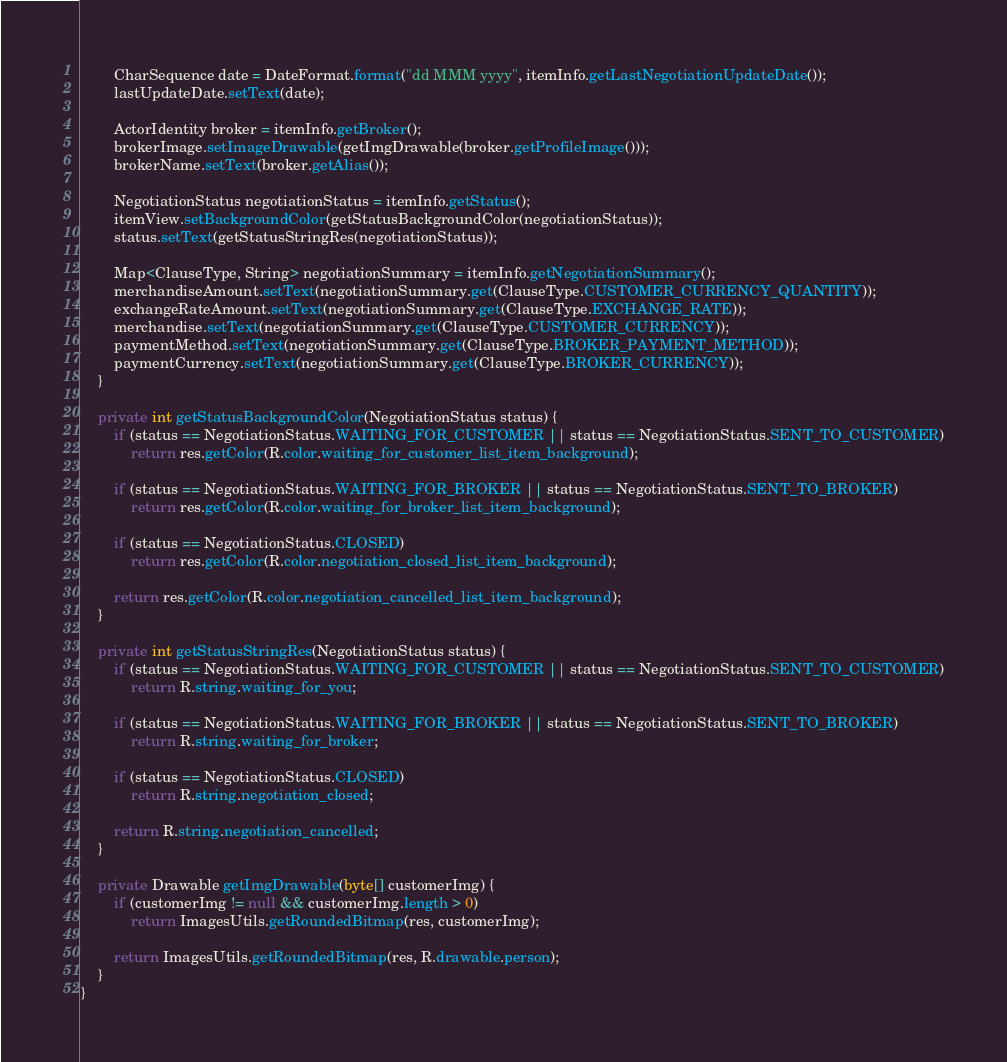Convert code to text. <code><loc_0><loc_0><loc_500><loc_500><_Java_>        CharSequence date = DateFormat.format("dd MMM yyyy", itemInfo.getLastNegotiationUpdateDate());
        lastUpdateDate.setText(date);

        ActorIdentity broker = itemInfo.getBroker();
        brokerImage.setImageDrawable(getImgDrawable(broker.getProfileImage()));
        brokerName.setText(broker.getAlias());

        NegotiationStatus negotiationStatus = itemInfo.getStatus();
        itemView.setBackgroundColor(getStatusBackgroundColor(negotiationStatus));
        status.setText(getStatusStringRes(negotiationStatus));

        Map<ClauseType, String> negotiationSummary = itemInfo.getNegotiationSummary();
        merchandiseAmount.setText(negotiationSummary.get(ClauseType.CUSTOMER_CURRENCY_QUANTITY));
        exchangeRateAmount.setText(negotiationSummary.get(ClauseType.EXCHANGE_RATE));
        merchandise.setText(negotiationSummary.get(ClauseType.CUSTOMER_CURRENCY));
        paymentMethod.setText(negotiationSummary.get(ClauseType.BROKER_PAYMENT_METHOD));
        paymentCurrency.setText(negotiationSummary.get(ClauseType.BROKER_CURRENCY));
    }

    private int getStatusBackgroundColor(NegotiationStatus status) {
        if (status == NegotiationStatus.WAITING_FOR_CUSTOMER || status == NegotiationStatus.SENT_TO_CUSTOMER)
            return res.getColor(R.color.waiting_for_customer_list_item_background);

        if (status == NegotiationStatus.WAITING_FOR_BROKER || status == NegotiationStatus.SENT_TO_BROKER)
            return res.getColor(R.color.waiting_for_broker_list_item_background);

        if (status == NegotiationStatus.CLOSED)
            return res.getColor(R.color.negotiation_closed_list_item_background);

        return res.getColor(R.color.negotiation_cancelled_list_item_background);
    }

    private int getStatusStringRes(NegotiationStatus status) {
        if (status == NegotiationStatus.WAITING_FOR_CUSTOMER || status == NegotiationStatus.SENT_TO_CUSTOMER)
            return R.string.waiting_for_you;

        if (status == NegotiationStatus.WAITING_FOR_BROKER || status == NegotiationStatus.SENT_TO_BROKER)
            return R.string.waiting_for_broker;

        if (status == NegotiationStatus.CLOSED)
            return R.string.negotiation_closed;

        return R.string.negotiation_cancelled;
    }

    private Drawable getImgDrawable(byte[] customerImg) {
        if (customerImg != null && customerImg.length > 0)
            return ImagesUtils.getRoundedBitmap(res, customerImg);

        return ImagesUtils.getRoundedBitmap(res, R.drawable.person);
    }
}
</code> 